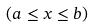Convert formula to latex. <formula><loc_0><loc_0><loc_500><loc_500>( a \leq x \leq b )</formula> 